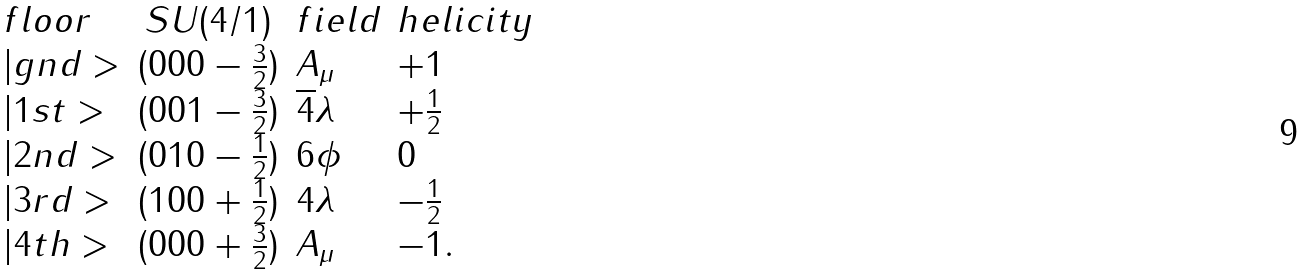<formula> <loc_0><loc_0><loc_500><loc_500>\begin{array} { l c l l } { f l o o r } & { S U ( 4 / 1 ) } & { f i e l d } & { h e l i c i t y } \\ { | g n d > } & { { ( 0 0 0 - \frac { 3 } { 2 } ) } } & { { A _ { \mu } } } & { + 1 } \\ { | 1 s t > } & { { ( 0 0 1 - \frac { 3 } { 2 } ) } } & { { \overline { 4 } \lambda } } & { { + \frac { 1 } { 2 } } } \\ { | 2 n d > } & { { ( 0 1 0 - \frac { 1 } { 2 } ) } } & { 6 \phi } & { 0 } \\ { | 3 r d > } & { { ( 1 0 0 + \frac { 1 } { 2 } ) } } & { 4 \lambda } & { { - \frac { 1 } { 2 } } } \\ { | 4 t h > } & { { ( 0 0 0 + \frac { 3 } { 2 } ) } } & { { A _ { \mu } } } & { - 1 . } \end{array}</formula> 